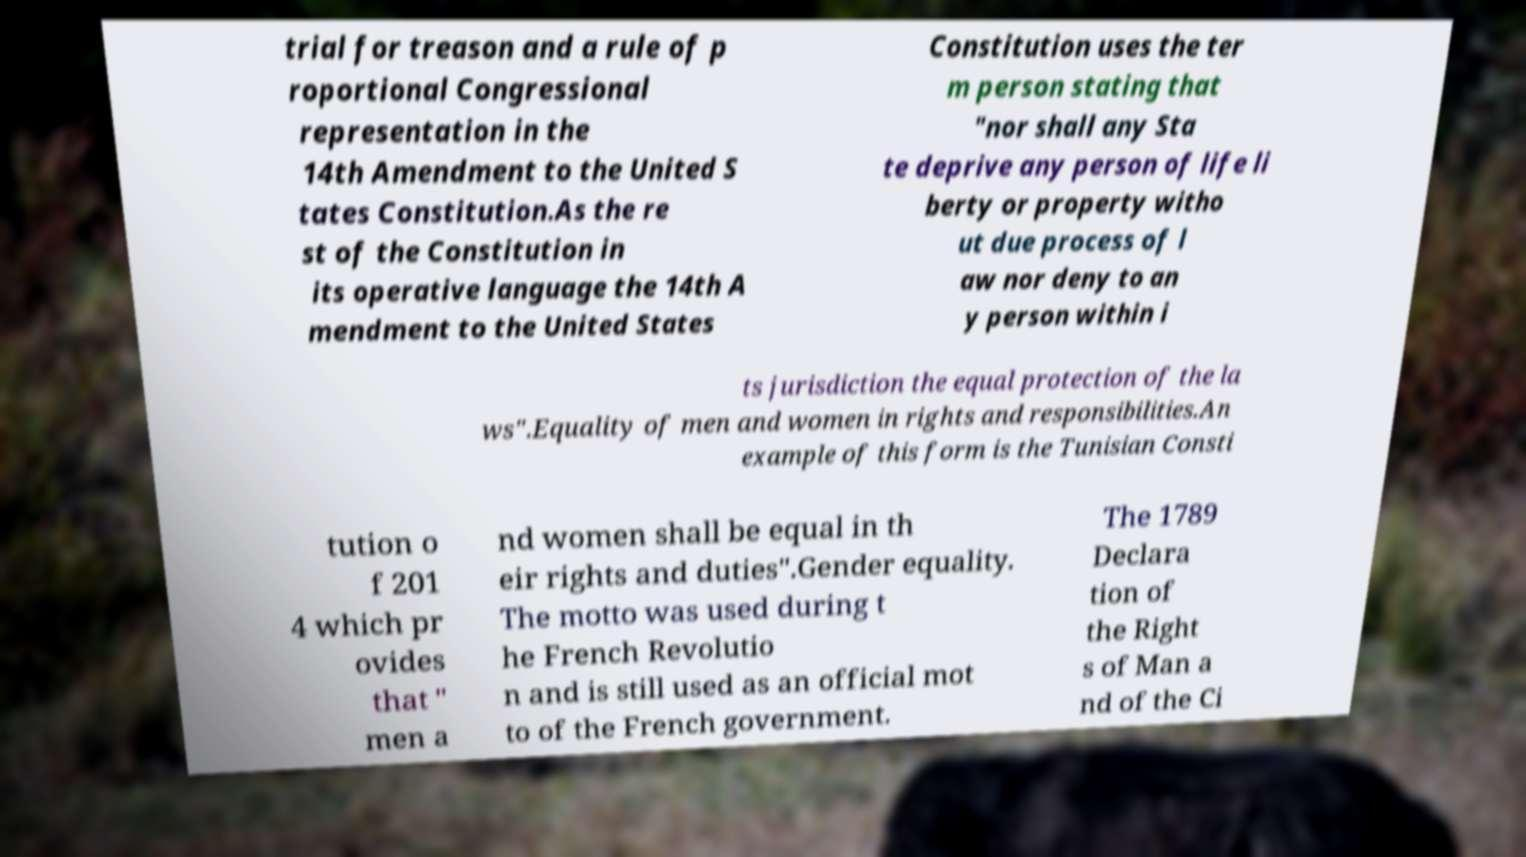Could you assist in decoding the text presented in this image and type it out clearly? trial for treason and a rule of p roportional Congressional representation in the 14th Amendment to the United S tates Constitution.As the re st of the Constitution in its operative language the 14th A mendment to the United States Constitution uses the ter m person stating that "nor shall any Sta te deprive any person of life li berty or property witho ut due process of l aw nor deny to an y person within i ts jurisdiction the equal protection of the la ws".Equality of men and women in rights and responsibilities.An example of this form is the Tunisian Consti tution o f 201 4 which pr ovides that " men a nd women shall be equal in th eir rights and duties".Gender equality. The motto was used during t he French Revolutio n and is still used as an official mot to of the French government. The 1789 Declara tion of the Right s of Man a nd of the Ci 